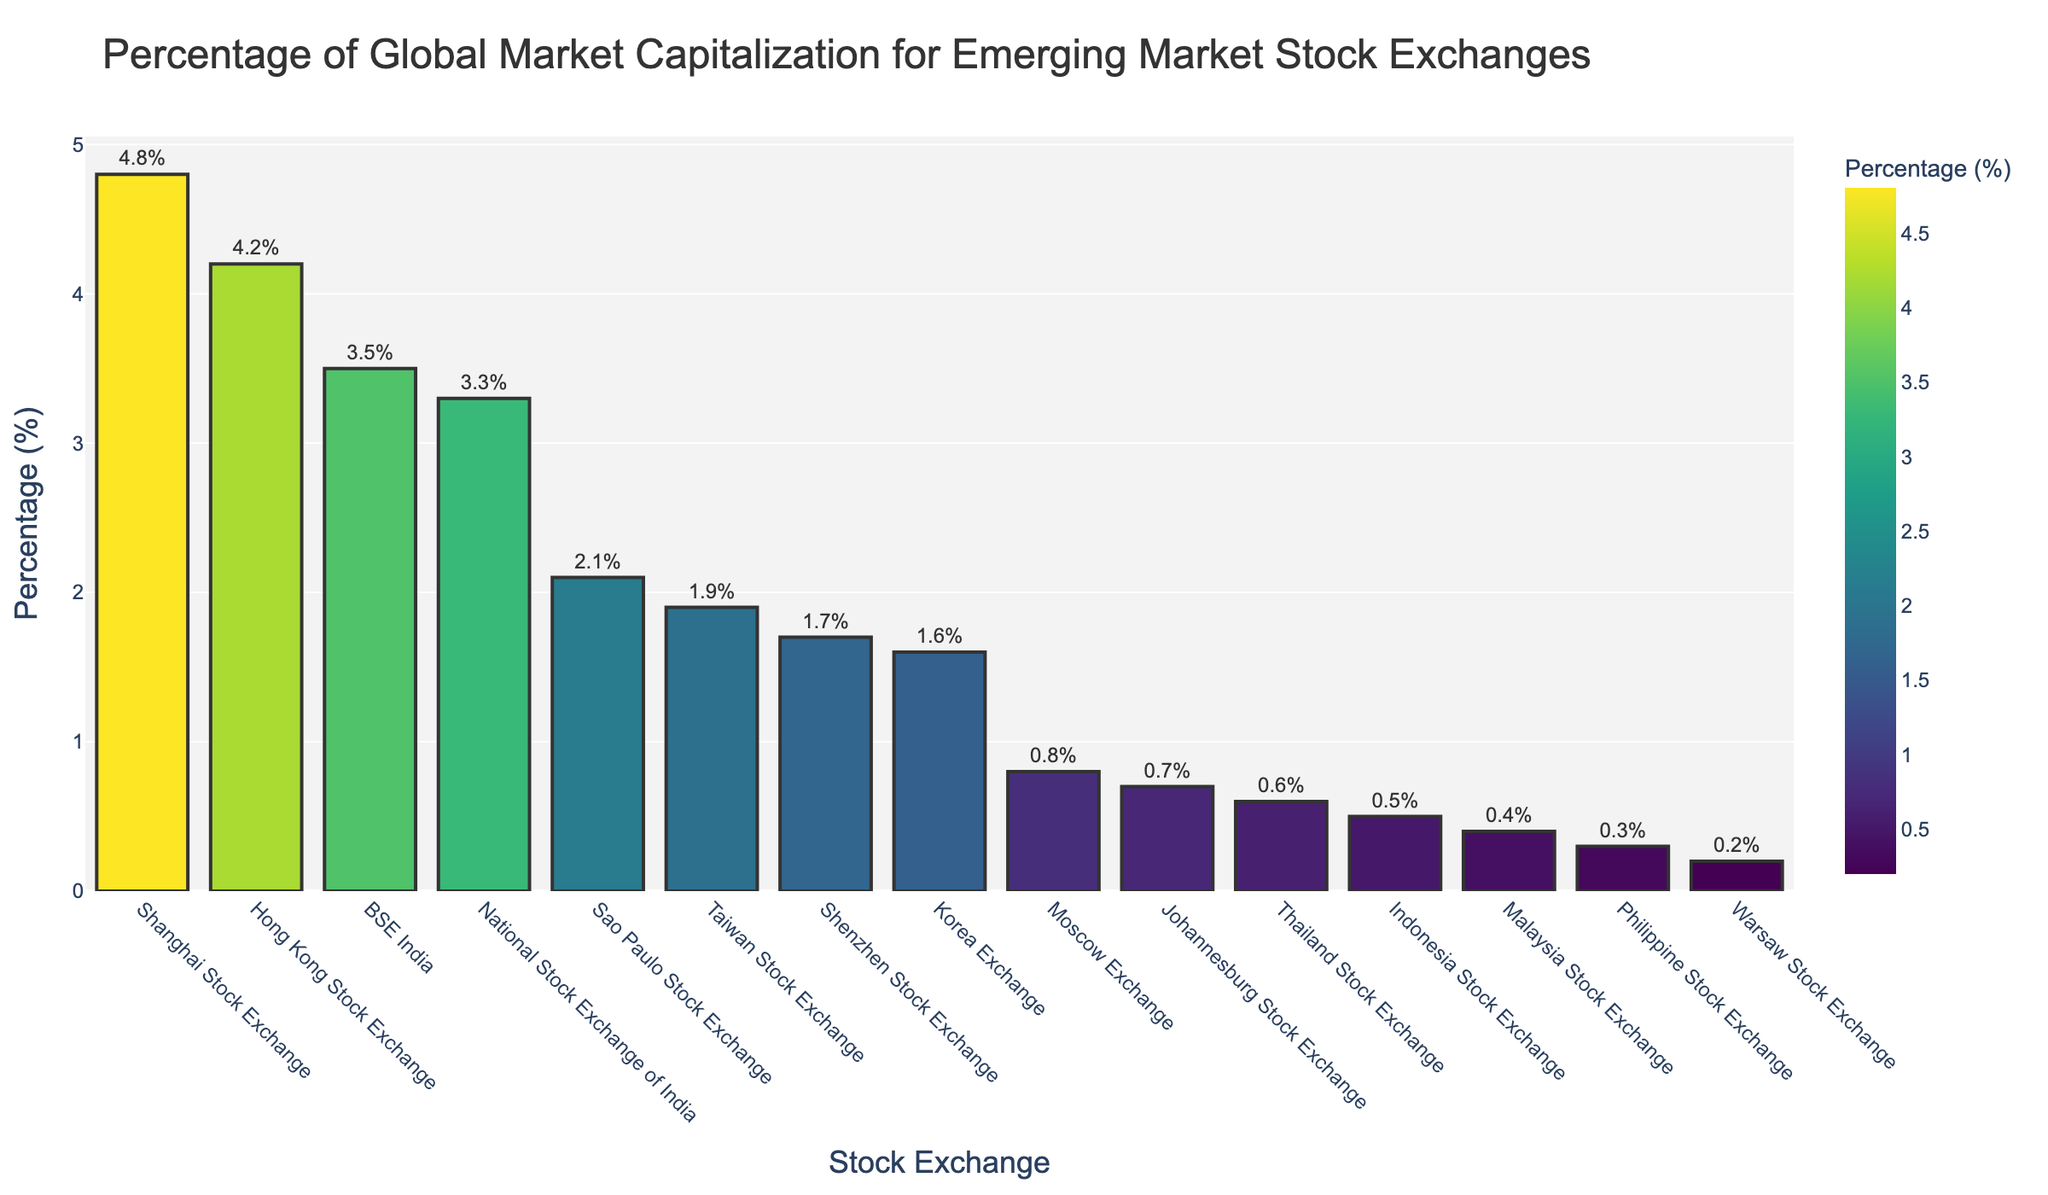What's the percentage difference between the Shanghai Stock Exchange and the Hong Kong Stock Exchange? The Shanghai Stock Exchange has a percentage of 4.8%, and the Hong Kong Stock Exchange has 4.2%. The difference is calculated as 4.8% - 4.2% = 0.6%
Answer: 0.6% Which exchange has the smallest percentage of global market capitalization? By inspecting the heights of the bars, the Warsaw Stock Exchange has the smallest percentage of global market capitalization at 0.2%.
Answer: Warsaw Stock Exchange What is the sum of the percentages for the BSE India and National Stock Exchange of India? The BSE India has a percentage of 3.5% and the National Stock Exchange of India has 3.3%. The total percentage is 3.5% + 3.3% = 6.8%
Answer: 6.8% Which stock exchange is represented by the tallest bar? The tallest bar corresponds to the Shanghai Stock Exchange, which has the highest percentage at 4.8%.
Answer: Shanghai Stock Exchange How does the percentage of the Shenzhen Stock Exchange compare with the Korea Exchange? The Shenzhen Stock Exchange has a percentage of 1.7%, and the Korea Exchange has 1.6%. Thus, the Shenzhen Stock Exchange has a slightly higher percentage.
Answer: Shenzhen Stock Exchange What is the combined percentage of global market capitalization for the top three exchanges? The top three exchanges are Shanghai Stock Exchange (4.8%), Hong Kong Stock Exchange (4.2%), and BSE India (3.5%). The combined percentage is 4.8% + 4.2% + 3.5% = 12.5%
Answer: 12.5% Which exchanges have percentages equal to or greater than 3%? The exchanges listed with percentages equal to or greater than 3% are Shanghai Stock Exchange (4.8%), Hong Kong Stock Exchange (4.2%), BSE India (3.5%), and National Stock Exchange of India (3.3%).
Answer: Shanghai Stock Exchange, Hong Kong Stock Exchange, BSE India, National Stock Exchange of India What is the median percentage value among all the stock exchanges? When the percentages are ordered from highest to lowest: 4.8%, 4.2%, 3.5%, 3.3%, 2.1%, 1.9%, 1.7%, 1.6%, 0.8%, 0.7%, 0.6%, 0.5%, 0.4%, 0.3%, 0.2%, the median percentage value, which is the middle value, is the value at the 8th position: 1.6%
Answer: 1.6% Which stock exchanges have percentages that are less than or equal to 1%? The exchanges with percentages less than or equal to 1% are Moscow Exchange (0.8%), Johannesburg Stock Exchange (0.7%), Thailand Stock Exchange (0.6%), Indonesia Stock Exchange (0.5%), Malaysia Stock Exchange (0.4%), Philippine Stock Exchange (0.3%), and Warsaw Stock Exchange (0.2%).
Answer: Moscow Exchange, Johannesburg Stock Exchange, Thailand Stock Exchange, Indonesia Stock Exchange, Malaysia Stock Exchange, Philippine Stock Exchange, Warsaw Stock Exchange 